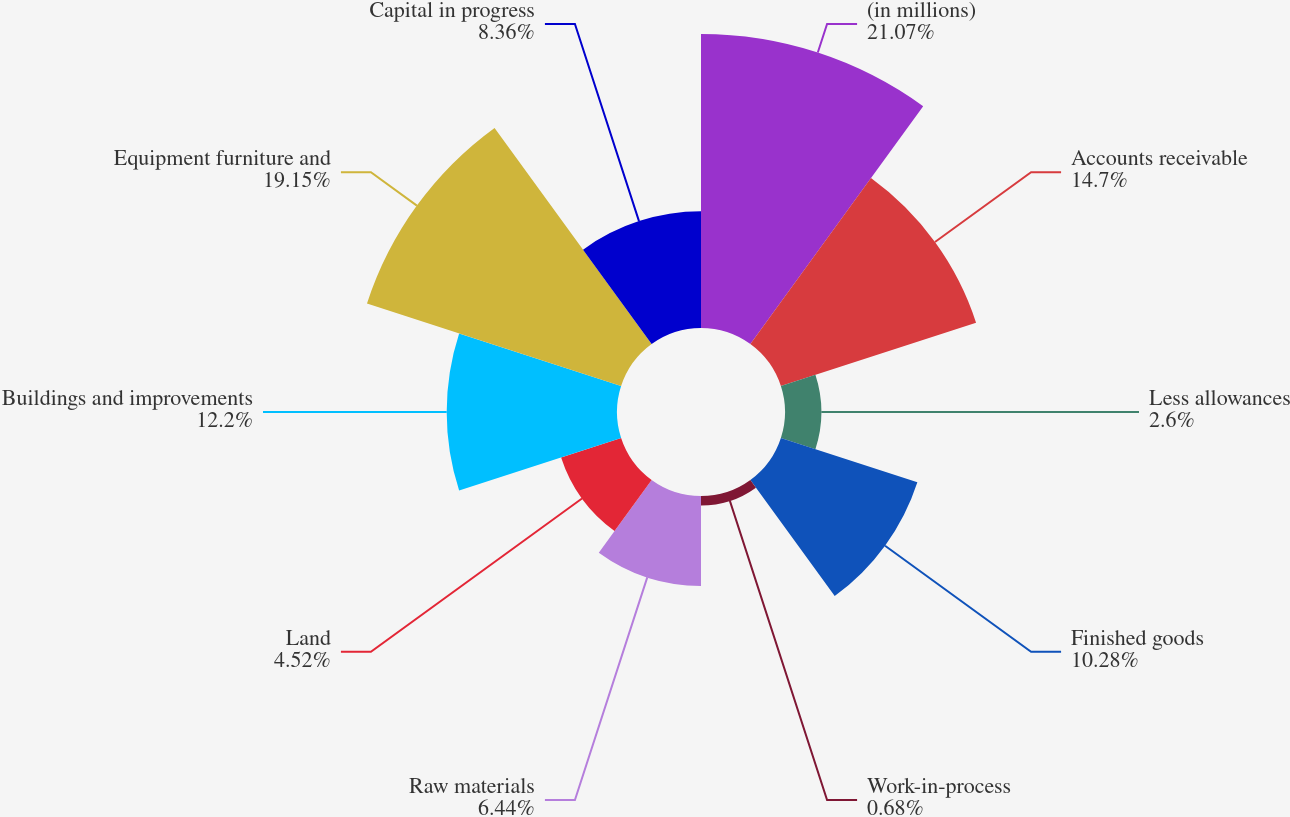Convert chart. <chart><loc_0><loc_0><loc_500><loc_500><pie_chart><fcel>(in millions)<fcel>Accounts receivable<fcel>Less allowances<fcel>Finished goods<fcel>Work-in-process<fcel>Raw materials<fcel>Land<fcel>Buildings and improvements<fcel>Equipment furniture and<fcel>Capital in progress<nl><fcel>21.06%<fcel>14.7%<fcel>2.6%<fcel>10.28%<fcel>0.68%<fcel>6.44%<fcel>4.52%<fcel>12.2%<fcel>19.14%<fcel>8.36%<nl></chart> 